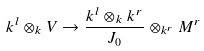Convert formula to latex. <formula><loc_0><loc_0><loc_500><loc_500>k ^ { l } \otimes _ { k } V \to \frac { k ^ { l } \otimes _ { k } k ^ { r } } { J _ { 0 } } \otimes _ { k ^ { r } } M ^ { r }</formula> 